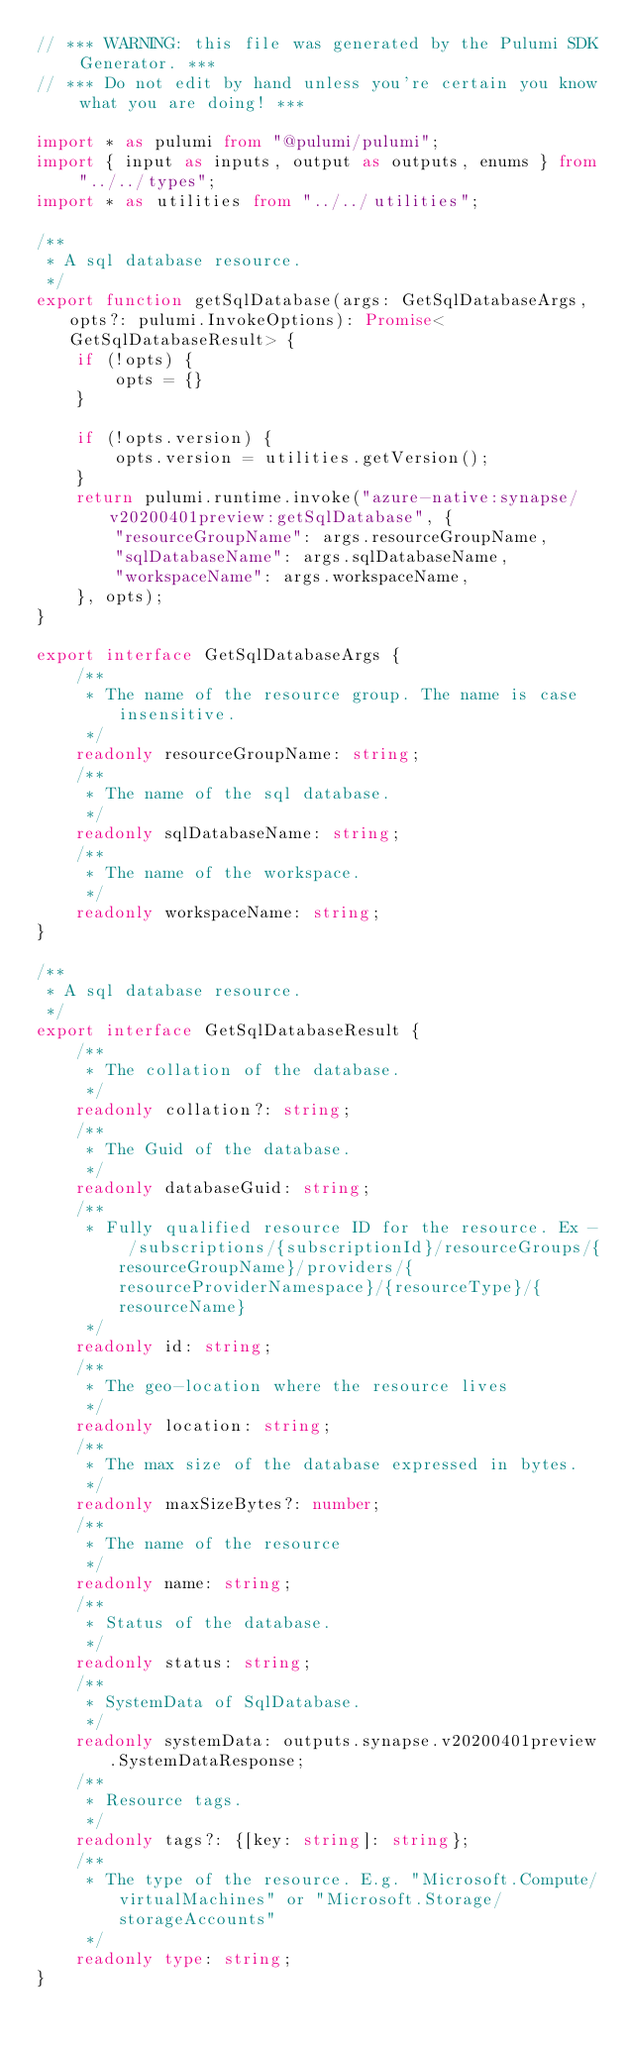Convert code to text. <code><loc_0><loc_0><loc_500><loc_500><_TypeScript_>// *** WARNING: this file was generated by the Pulumi SDK Generator. ***
// *** Do not edit by hand unless you're certain you know what you are doing! ***

import * as pulumi from "@pulumi/pulumi";
import { input as inputs, output as outputs, enums } from "../../types";
import * as utilities from "../../utilities";

/**
 * A sql database resource.
 */
export function getSqlDatabase(args: GetSqlDatabaseArgs, opts?: pulumi.InvokeOptions): Promise<GetSqlDatabaseResult> {
    if (!opts) {
        opts = {}
    }

    if (!opts.version) {
        opts.version = utilities.getVersion();
    }
    return pulumi.runtime.invoke("azure-native:synapse/v20200401preview:getSqlDatabase", {
        "resourceGroupName": args.resourceGroupName,
        "sqlDatabaseName": args.sqlDatabaseName,
        "workspaceName": args.workspaceName,
    }, opts);
}

export interface GetSqlDatabaseArgs {
    /**
     * The name of the resource group. The name is case insensitive.
     */
    readonly resourceGroupName: string;
    /**
     * The name of the sql database.
     */
    readonly sqlDatabaseName: string;
    /**
     * The name of the workspace.
     */
    readonly workspaceName: string;
}

/**
 * A sql database resource.
 */
export interface GetSqlDatabaseResult {
    /**
     * The collation of the database.
     */
    readonly collation?: string;
    /**
     * The Guid of the database.
     */
    readonly databaseGuid: string;
    /**
     * Fully qualified resource ID for the resource. Ex - /subscriptions/{subscriptionId}/resourceGroups/{resourceGroupName}/providers/{resourceProviderNamespace}/{resourceType}/{resourceName}
     */
    readonly id: string;
    /**
     * The geo-location where the resource lives
     */
    readonly location: string;
    /**
     * The max size of the database expressed in bytes.
     */
    readonly maxSizeBytes?: number;
    /**
     * The name of the resource
     */
    readonly name: string;
    /**
     * Status of the database.
     */
    readonly status: string;
    /**
     * SystemData of SqlDatabase.
     */
    readonly systemData: outputs.synapse.v20200401preview.SystemDataResponse;
    /**
     * Resource tags.
     */
    readonly tags?: {[key: string]: string};
    /**
     * The type of the resource. E.g. "Microsoft.Compute/virtualMachines" or "Microsoft.Storage/storageAccounts"
     */
    readonly type: string;
}
</code> 